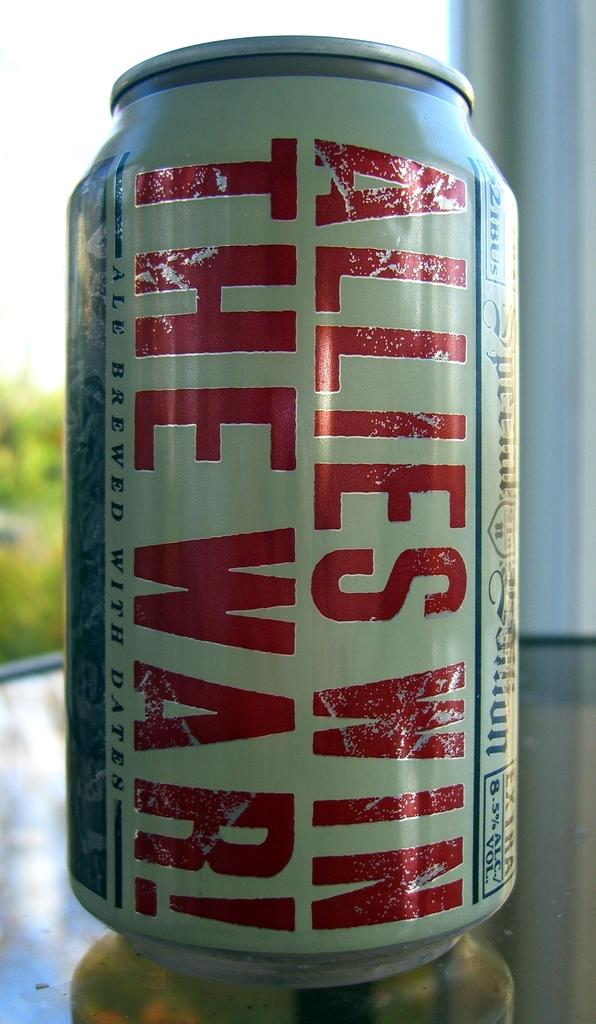<image>
Summarize the visual content of the image. a can that says Allies Win on it 